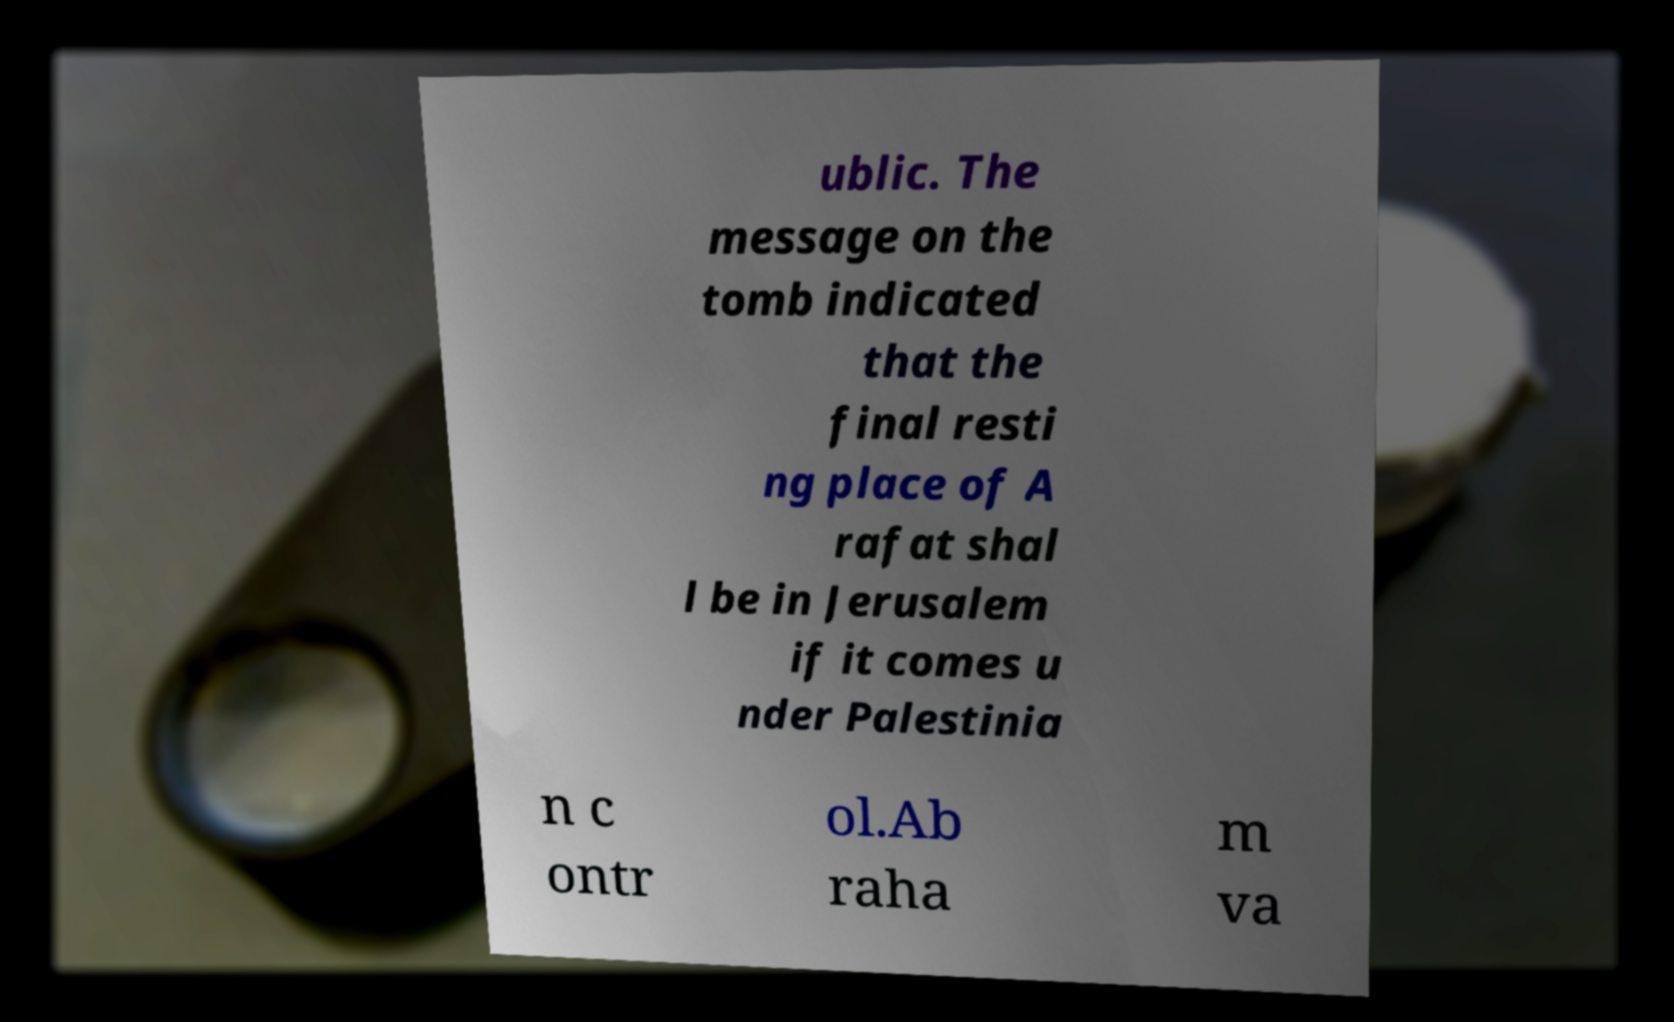Can you accurately transcribe the text from the provided image for me? ublic. The message on the tomb indicated that the final resti ng place of A rafat shal l be in Jerusalem if it comes u nder Palestinia n c ontr ol.Ab raha m va 